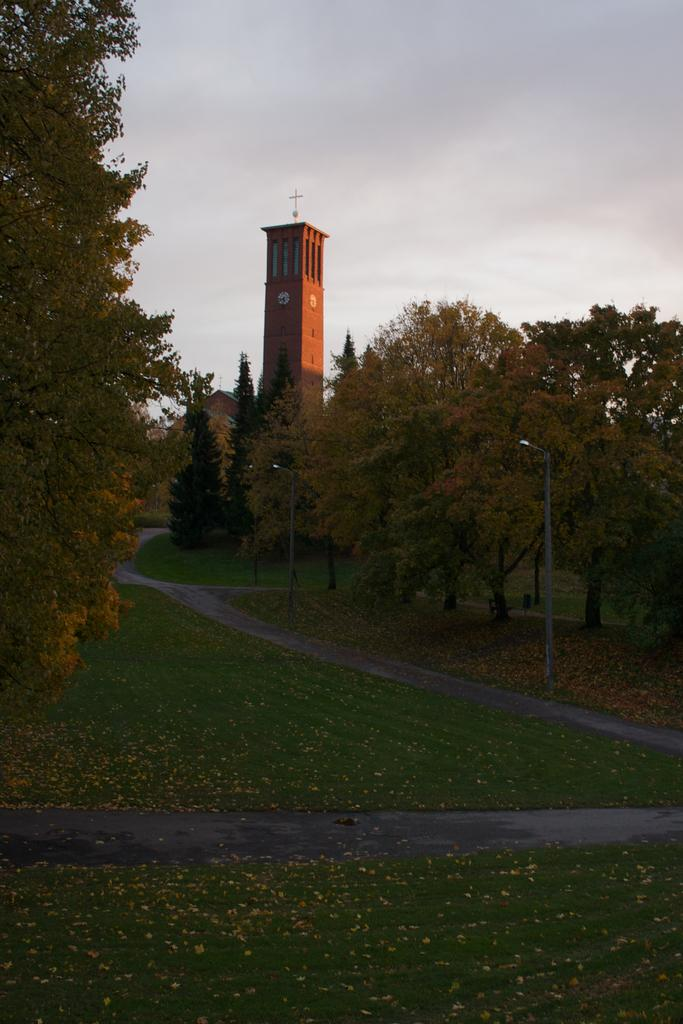What can be seen in the background of the image? There is a tower and the sky visible in the background of the image. What type of objects are present in the image? There are clocks, a cross symbol, trees, grass, light poles, and a pathway in the image. Can you describe the pathway in the image? There is a pathway in the image, which suggests that it might be a public area or a park. What other objects can be seen in the image? There are other objects in the image, but their specific details are not mentioned in the provided facts. How many chickens are used to create the thread in the image? There are no chickens or thread present in the image. What type of ants can be seen crawling on the cross symbol in the image? There are no ants present in the image, and therefore no such activity can be observed. 